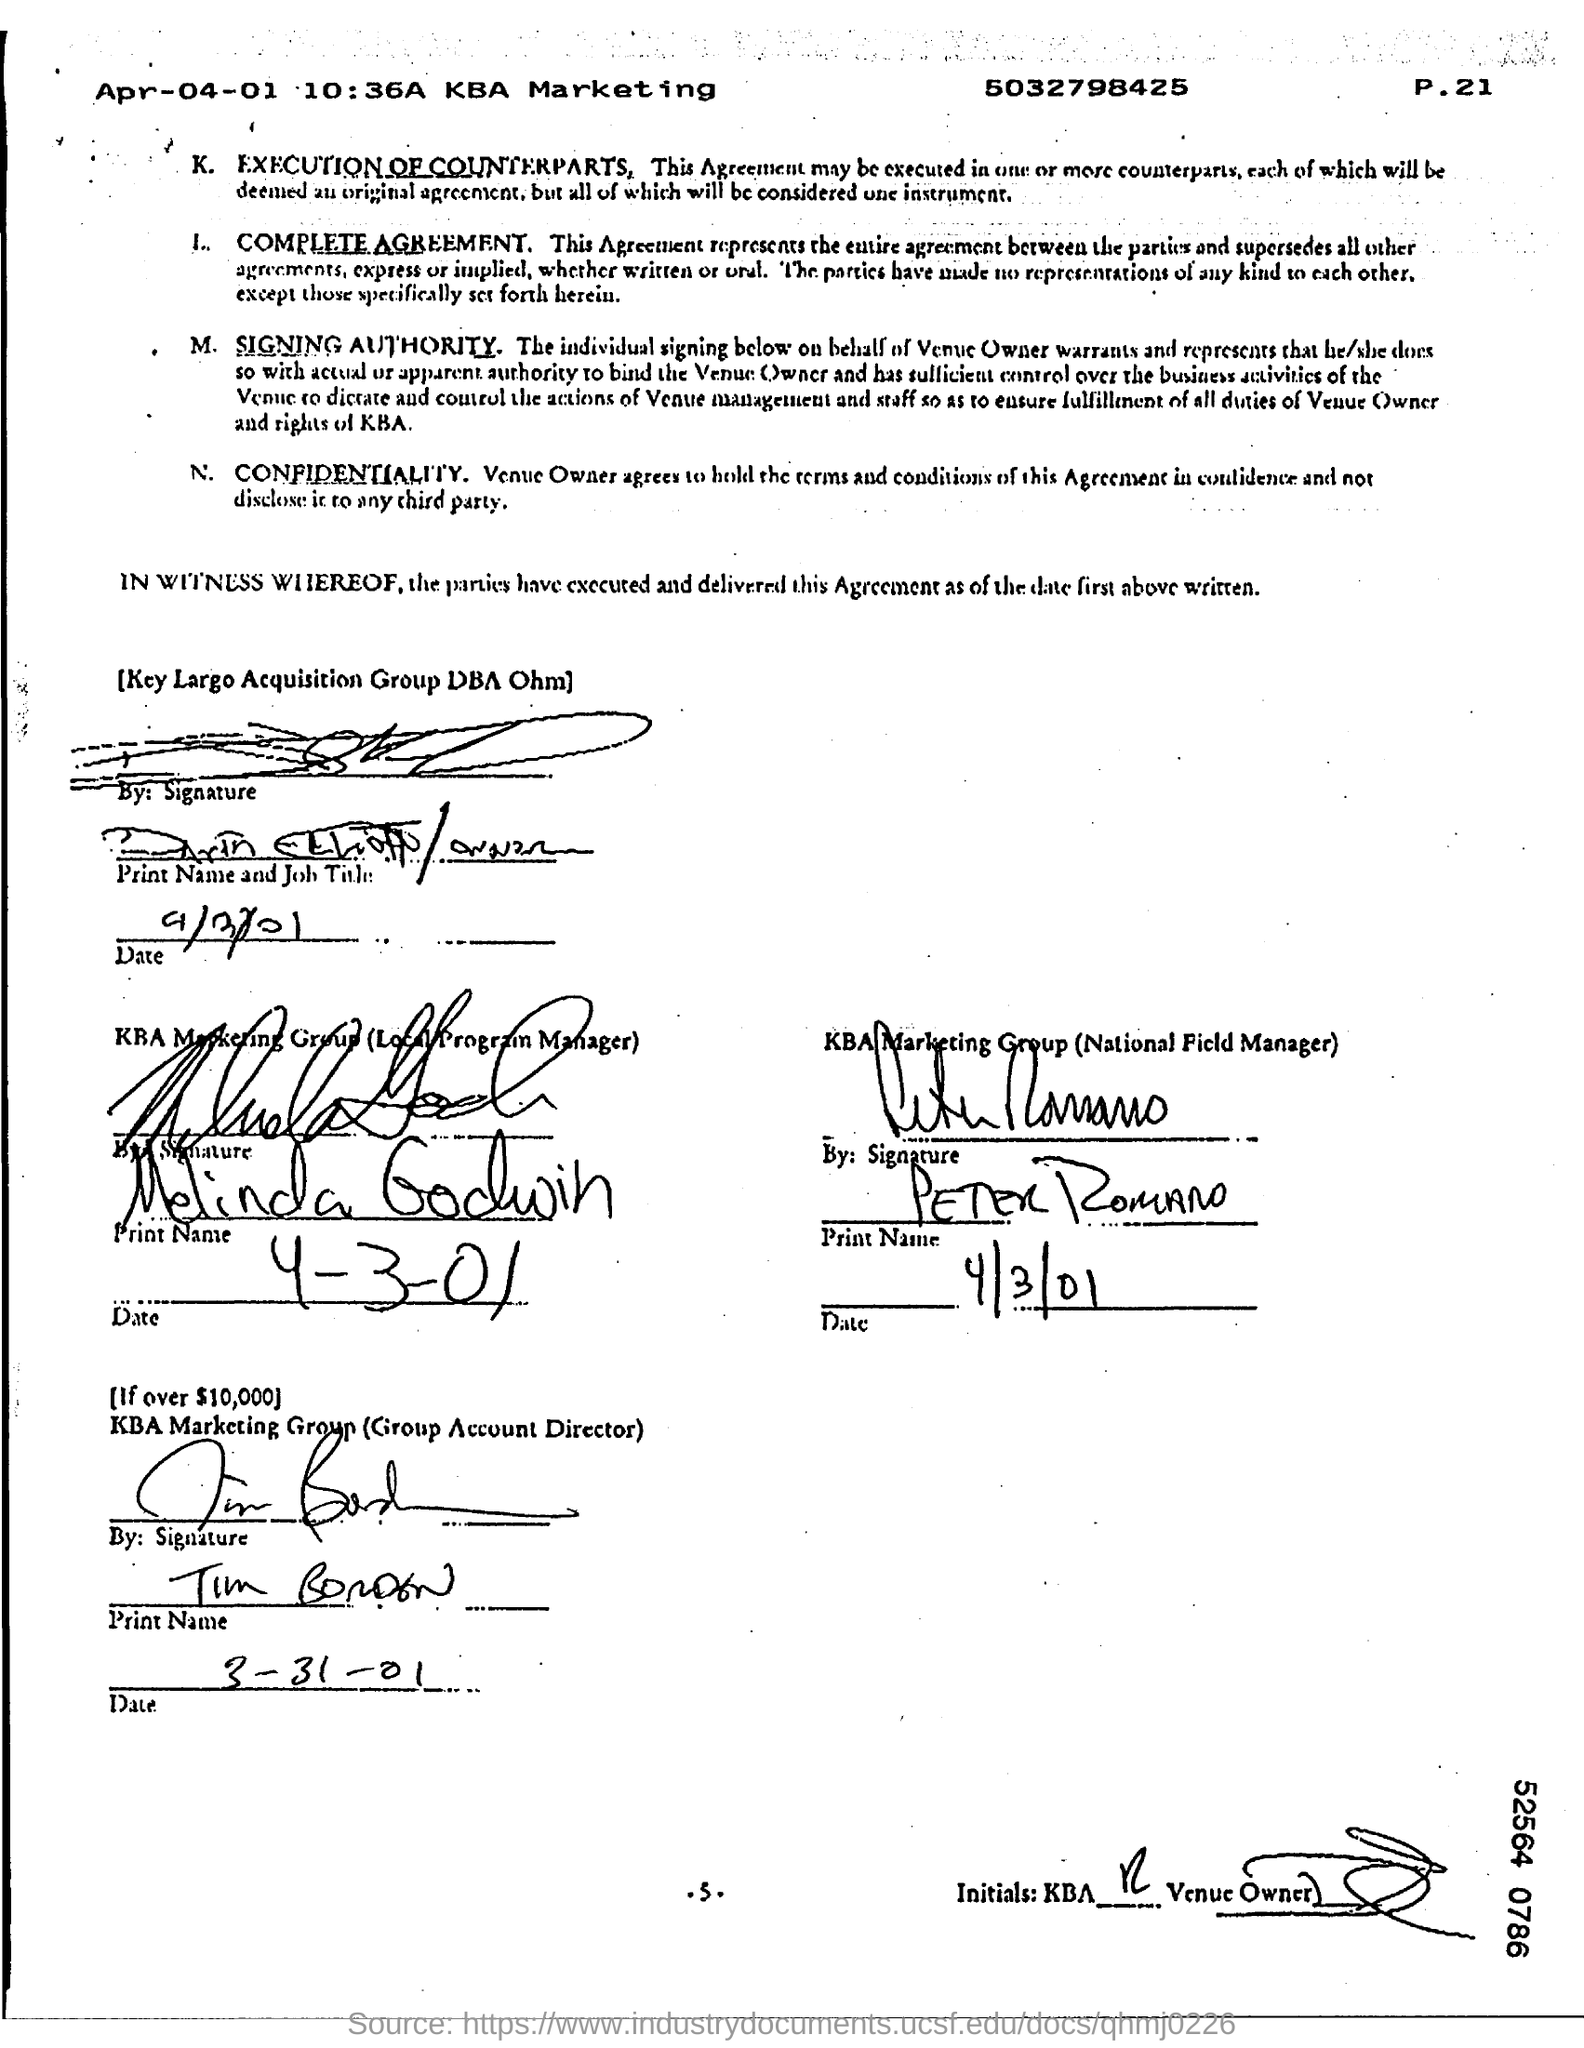Point out several critical features in this image. The document is dated April 4, 2001. Melinda Godwin is the Local Program Manager. The National Field Manager of KBA Marketing Group is Peter Romano. 